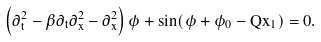<formula> <loc_0><loc_0><loc_500><loc_500>\left ( \partial ^ { 2 } _ { t } - \beta \partial _ { t } \partial _ { x } ^ { 2 } - \partial _ { x } ^ { 2 } \right ) \phi + \sin ( \phi + \phi _ { 0 } - Q x _ { 1 } ) = 0 .</formula> 